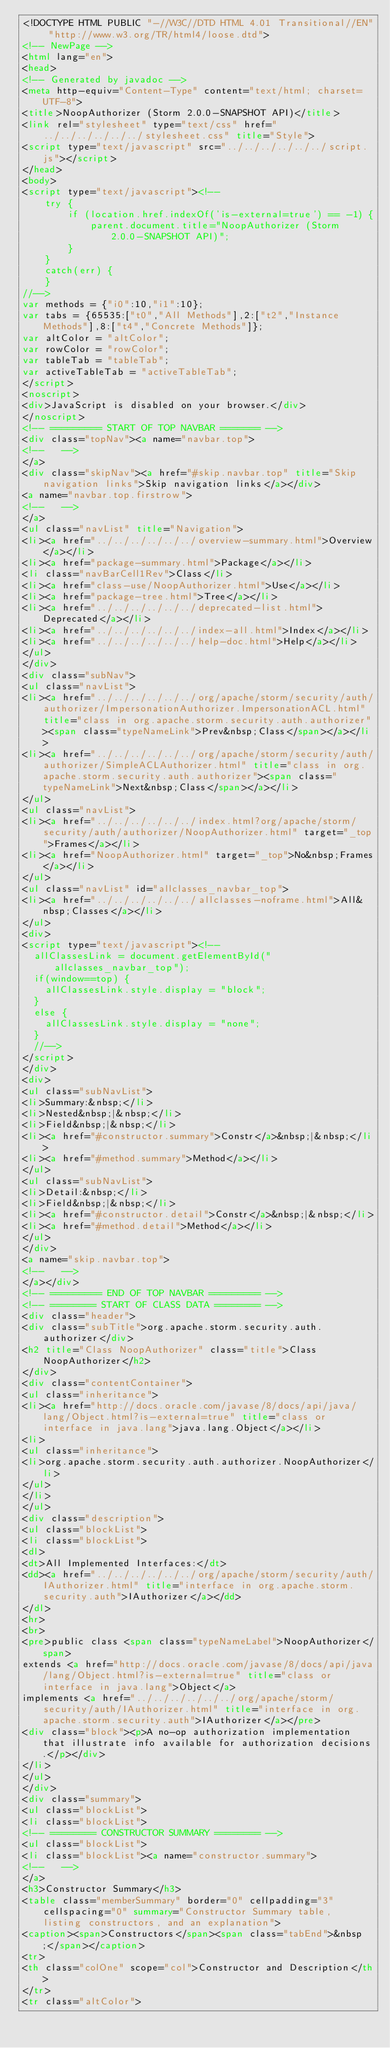Convert code to text. <code><loc_0><loc_0><loc_500><loc_500><_HTML_><!DOCTYPE HTML PUBLIC "-//W3C//DTD HTML 4.01 Transitional//EN" "http://www.w3.org/TR/html4/loose.dtd">
<!-- NewPage -->
<html lang="en">
<head>
<!-- Generated by javadoc -->
<meta http-equiv="Content-Type" content="text/html; charset=UTF-8">
<title>NoopAuthorizer (Storm 2.0.0-SNAPSHOT API)</title>
<link rel="stylesheet" type="text/css" href="../../../../../../stylesheet.css" title="Style">
<script type="text/javascript" src="../../../../../../script.js"></script>
</head>
<body>
<script type="text/javascript"><!--
    try {
        if (location.href.indexOf('is-external=true') == -1) {
            parent.document.title="NoopAuthorizer (Storm 2.0.0-SNAPSHOT API)";
        }
    }
    catch(err) {
    }
//-->
var methods = {"i0":10,"i1":10};
var tabs = {65535:["t0","All Methods"],2:["t2","Instance Methods"],8:["t4","Concrete Methods"]};
var altColor = "altColor";
var rowColor = "rowColor";
var tableTab = "tableTab";
var activeTableTab = "activeTableTab";
</script>
<noscript>
<div>JavaScript is disabled on your browser.</div>
</noscript>
<!-- ========= START OF TOP NAVBAR ======= -->
<div class="topNav"><a name="navbar.top">
<!--   -->
</a>
<div class="skipNav"><a href="#skip.navbar.top" title="Skip navigation links">Skip navigation links</a></div>
<a name="navbar.top.firstrow">
<!--   -->
</a>
<ul class="navList" title="Navigation">
<li><a href="../../../../../../overview-summary.html">Overview</a></li>
<li><a href="package-summary.html">Package</a></li>
<li class="navBarCell1Rev">Class</li>
<li><a href="class-use/NoopAuthorizer.html">Use</a></li>
<li><a href="package-tree.html">Tree</a></li>
<li><a href="../../../../../../deprecated-list.html">Deprecated</a></li>
<li><a href="../../../../../../index-all.html">Index</a></li>
<li><a href="../../../../../../help-doc.html">Help</a></li>
</ul>
</div>
<div class="subNav">
<ul class="navList">
<li><a href="../../../../../../org/apache/storm/security/auth/authorizer/ImpersonationAuthorizer.ImpersonationACL.html" title="class in org.apache.storm.security.auth.authorizer"><span class="typeNameLink">Prev&nbsp;Class</span></a></li>
<li><a href="../../../../../../org/apache/storm/security/auth/authorizer/SimpleACLAuthorizer.html" title="class in org.apache.storm.security.auth.authorizer"><span class="typeNameLink">Next&nbsp;Class</span></a></li>
</ul>
<ul class="navList">
<li><a href="../../../../../../index.html?org/apache/storm/security/auth/authorizer/NoopAuthorizer.html" target="_top">Frames</a></li>
<li><a href="NoopAuthorizer.html" target="_top">No&nbsp;Frames</a></li>
</ul>
<ul class="navList" id="allclasses_navbar_top">
<li><a href="../../../../../../allclasses-noframe.html">All&nbsp;Classes</a></li>
</ul>
<div>
<script type="text/javascript"><!--
  allClassesLink = document.getElementById("allclasses_navbar_top");
  if(window==top) {
    allClassesLink.style.display = "block";
  }
  else {
    allClassesLink.style.display = "none";
  }
  //-->
</script>
</div>
<div>
<ul class="subNavList">
<li>Summary:&nbsp;</li>
<li>Nested&nbsp;|&nbsp;</li>
<li>Field&nbsp;|&nbsp;</li>
<li><a href="#constructor.summary">Constr</a>&nbsp;|&nbsp;</li>
<li><a href="#method.summary">Method</a></li>
</ul>
<ul class="subNavList">
<li>Detail:&nbsp;</li>
<li>Field&nbsp;|&nbsp;</li>
<li><a href="#constructor.detail">Constr</a>&nbsp;|&nbsp;</li>
<li><a href="#method.detail">Method</a></li>
</ul>
</div>
<a name="skip.navbar.top">
<!--   -->
</a></div>
<!-- ========= END OF TOP NAVBAR ========= -->
<!-- ======== START OF CLASS DATA ======== -->
<div class="header">
<div class="subTitle">org.apache.storm.security.auth.authorizer</div>
<h2 title="Class NoopAuthorizer" class="title">Class NoopAuthorizer</h2>
</div>
<div class="contentContainer">
<ul class="inheritance">
<li><a href="http://docs.oracle.com/javase/8/docs/api/java/lang/Object.html?is-external=true" title="class or interface in java.lang">java.lang.Object</a></li>
<li>
<ul class="inheritance">
<li>org.apache.storm.security.auth.authorizer.NoopAuthorizer</li>
</ul>
</li>
</ul>
<div class="description">
<ul class="blockList">
<li class="blockList">
<dl>
<dt>All Implemented Interfaces:</dt>
<dd><a href="../../../../../../org/apache/storm/security/auth/IAuthorizer.html" title="interface in org.apache.storm.security.auth">IAuthorizer</a></dd>
</dl>
<hr>
<br>
<pre>public class <span class="typeNameLabel">NoopAuthorizer</span>
extends <a href="http://docs.oracle.com/javase/8/docs/api/java/lang/Object.html?is-external=true" title="class or interface in java.lang">Object</a>
implements <a href="../../../../../../org/apache/storm/security/auth/IAuthorizer.html" title="interface in org.apache.storm.security.auth">IAuthorizer</a></pre>
<div class="block"><p>A no-op authorization implementation that illustrate info available for authorization decisions.</p></div>
</li>
</ul>
</div>
<div class="summary">
<ul class="blockList">
<li class="blockList">
<!-- ======== CONSTRUCTOR SUMMARY ======== -->
<ul class="blockList">
<li class="blockList"><a name="constructor.summary">
<!--   -->
</a>
<h3>Constructor Summary</h3>
<table class="memberSummary" border="0" cellpadding="3" cellspacing="0" summary="Constructor Summary table, listing constructors, and an explanation">
<caption><span>Constructors</span><span class="tabEnd">&nbsp;</span></caption>
<tr>
<th class="colOne" scope="col">Constructor and Description</th>
</tr>
<tr class="altColor"></code> 